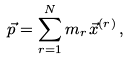Convert formula to latex. <formula><loc_0><loc_0><loc_500><loc_500>\vec { p } = \sum _ { r = 1 } ^ { N } m _ { r } \, \vec { x } ^ { ( r ) } \, ,</formula> 